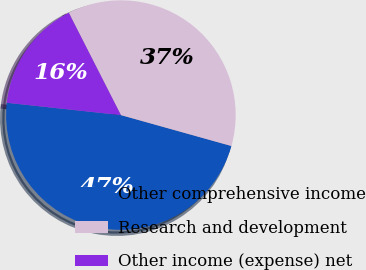<chart> <loc_0><loc_0><loc_500><loc_500><pie_chart><fcel>Other comprehensive income<fcel>Research and development<fcel>Other income (expense) net<nl><fcel>47.37%<fcel>36.84%<fcel>15.79%<nl></chart> 